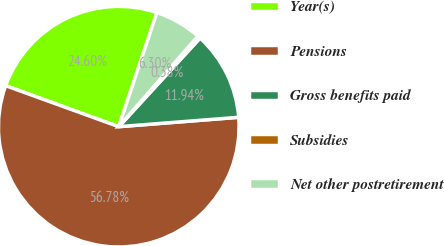<chart> <loc_0><loc_0><loc_500><loc_500><pie_chart><fcel>Year(s)<fcel>Pensions<fcel>Gross benefits paid<fcel>Subsidies<fcel>Net other postretirement<nl><fcel>24.6%<fcel>56.78%<fcel>11.94%<fcel>0.38%<fcel>6.3%<nl></chart> 